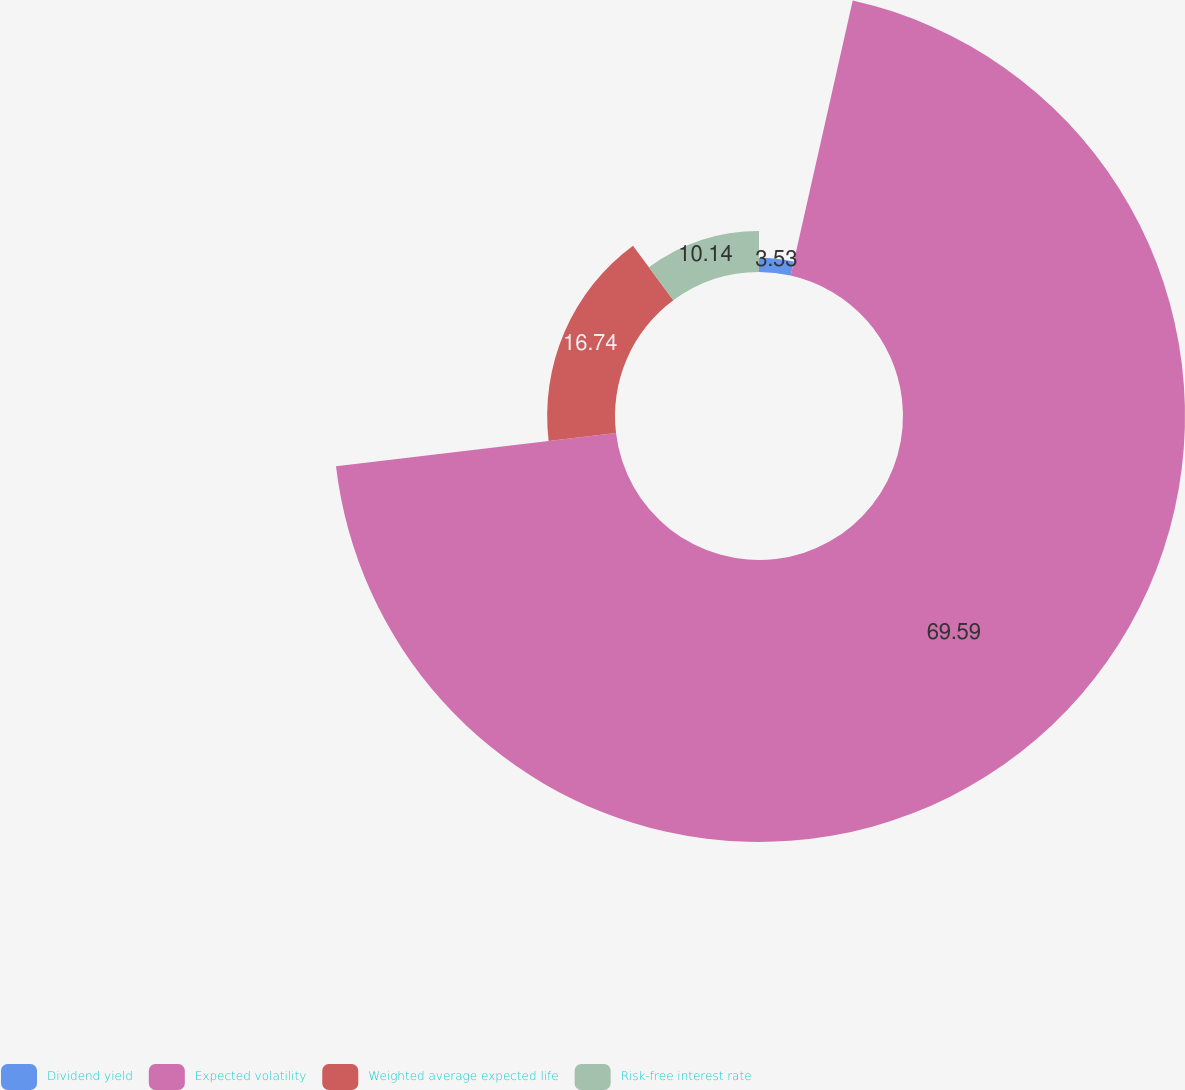Convert chart to OTSL. <chart><loc_0><loc_0><loc_500><loc_500><pie_chart><fcel>Dividend yield<fcel>Expected volatility<fcel>Weighted average expected life<fcel>Risk-free interest rate<nl><fcel>3.53%<fcel>69.58%<fcel>16.74%<fcel>10.14%<nl></chart> 